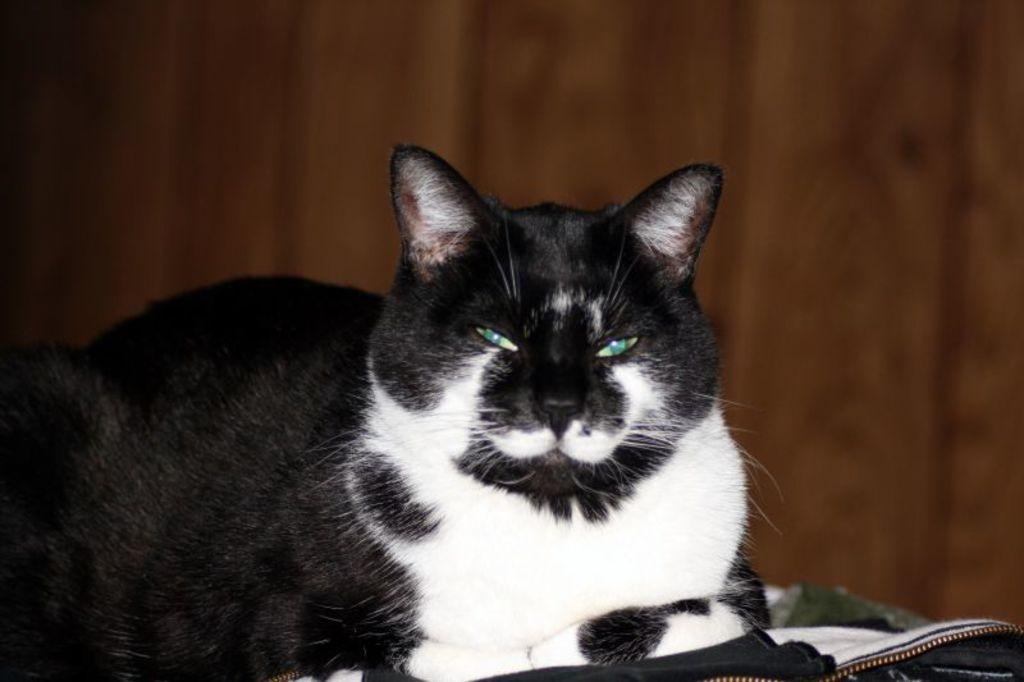What is the main subject in the front of the image? There is a cat in the front of the image. What else can be seen in the front of the image besides the cat? There is an object in the front of the image. Can you describe the background of the image? The background of the image is blurry. Where is the lunchroom located in the image? There is no mention of a lunchroom in the image, so it cannot be located. How far away is the bat from the cat in the image? There is no bat present in the image, so it cannot be compared to the cat's distance. 